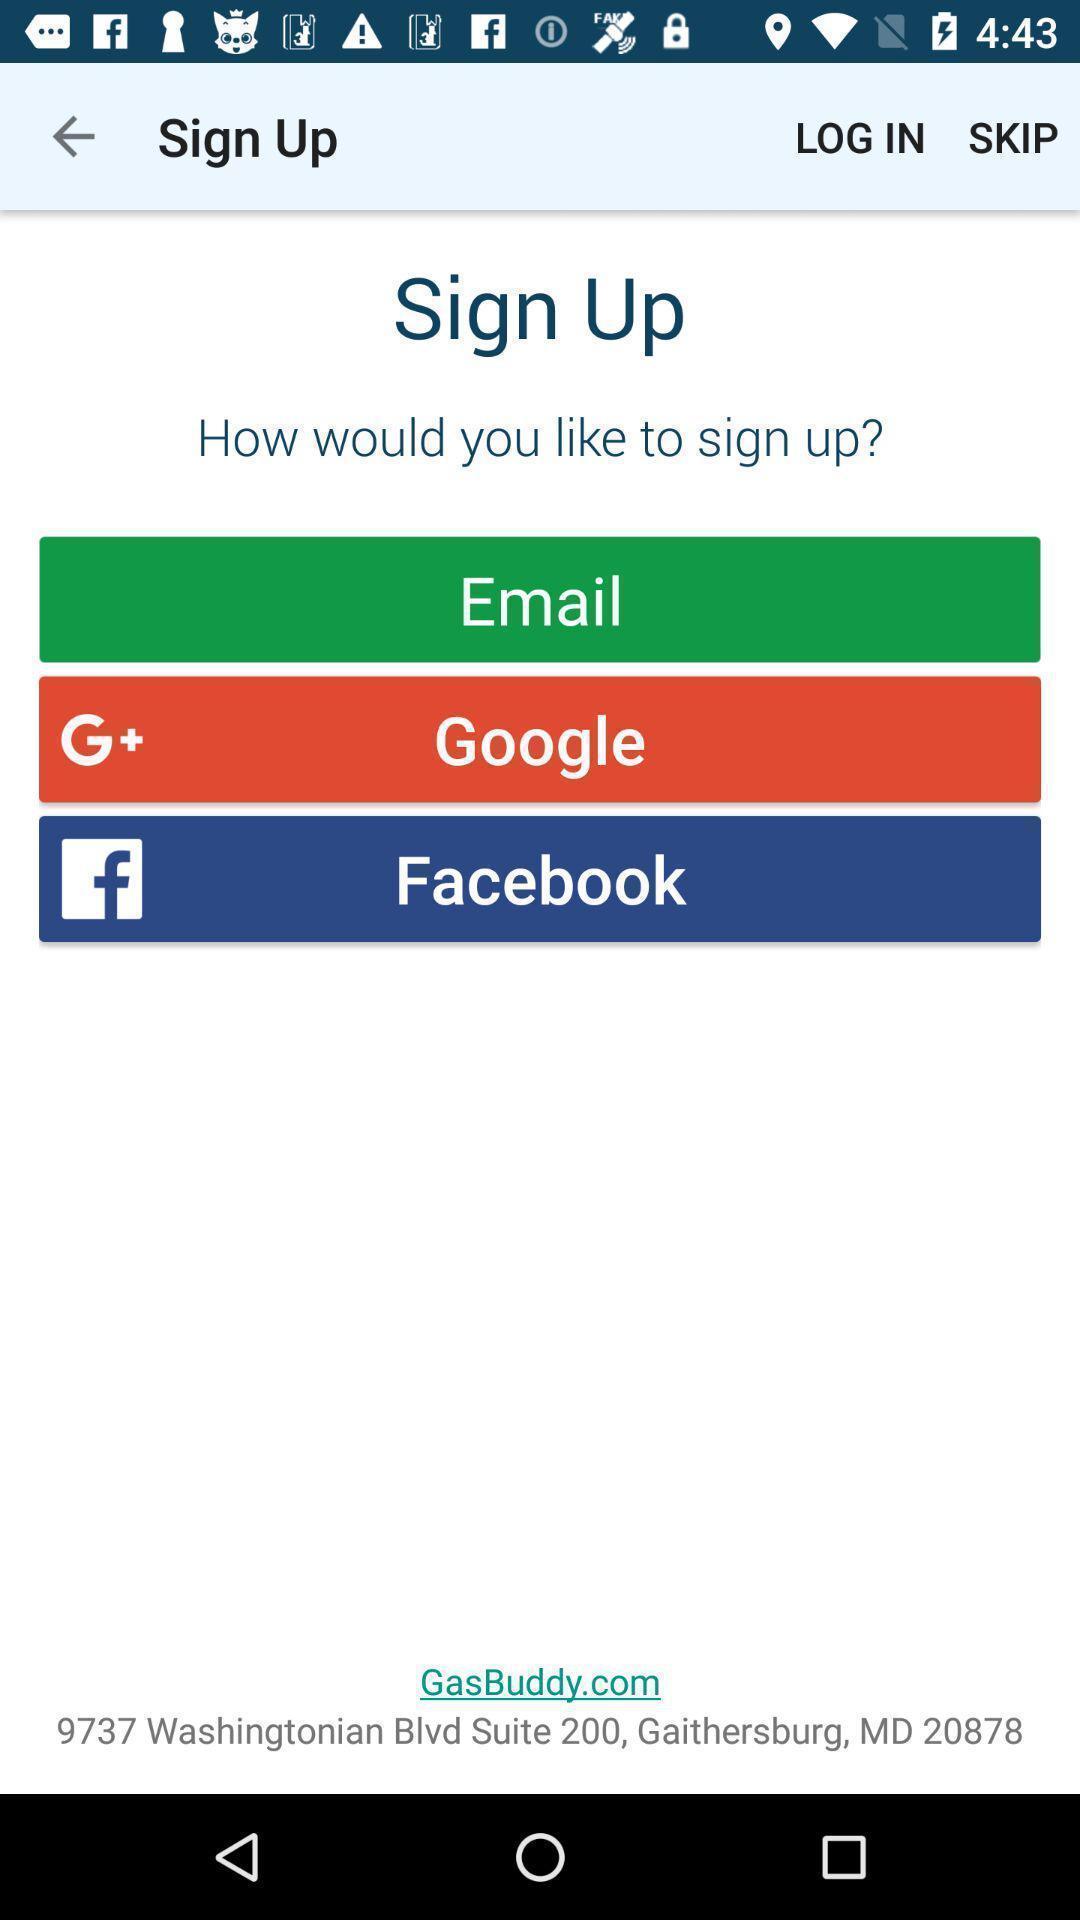What details can you identify in this image? Sign up page of a gas station locator app. 